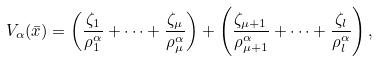Convert formula to latex. <formula><loc_0><loc_0><loc_500><loc_500>V _ { \alpha } ( \bar { x } ) = \left ( \frac { \zeta _ { 1 } } { \rho _ { 1 } ^ { \alpha } } + \dots + \frac { \zeta _ { \mu } } { \rho _ { \mu } ^ { \alpha } } \right ) + \left ( \frac { \zeta _ { \mu + 1 } } { \rho _ { \mu + 1 } ^ { \alpha } } + \dots + \frac { \zeta _ { l } } { \rho _ { l } ^ { \alpha } } \right ) ,</formula> 